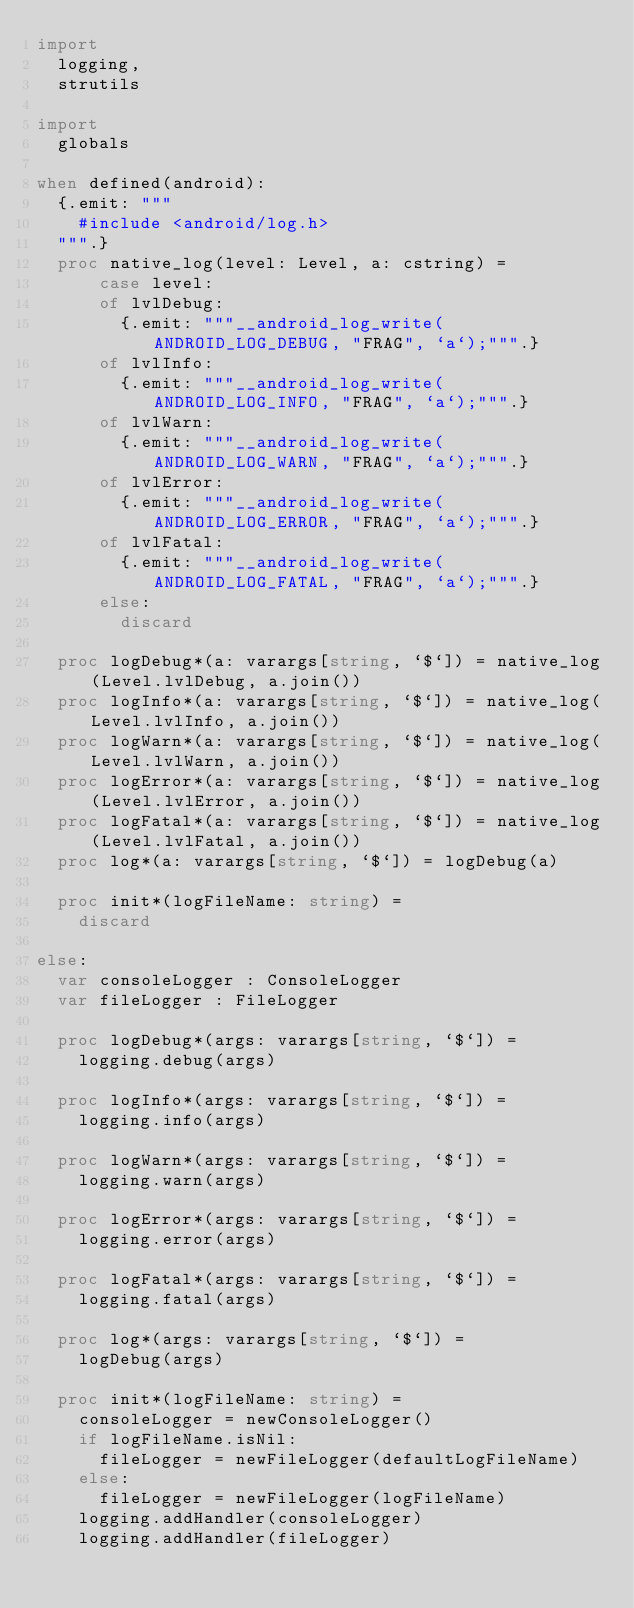Convert code to text. <code><loc_0><loc_0><loc_500><loc_500><_Nim_>import
  logging,
  strutils

import
  globals

when defined(android):
  {.emit: """
    #include <android/log.h>
  """.}
  proc native_log(level: Level, a: cstring) =
      case level:
      of lvlDebug:
        {.emit: """__android_log_write(ANDROID_LOG_DEBUG, "FRAG", `a`);""".}
      of lvlInfo:
        {.emit: """__android_log_write(ANDROID_LOG_INFO, "FRAG", `a`);""".}
      of lvlWarn:
        {.emit: """__android_log_write(ANDROID_LOG_WARN, "FRAG", `a`);""".}
      of lvlError:
        {.emit: """__android_log_write(ANDROID_LOG_ERROR, "FRAG", `a`);""".}
      of lvlFatal:
        {.emit: """__android_log_write(ANDROID_LOG_FATAL, "FRAG", `a`);""".}
      else:
        discard

  proc logDebug*(a: varargs[string, `$`]) = native_log(Level.lvlDebug, a.join())
  proc logInfo*(a: varargs[string, `$`]) = native_log(Level.lvlInfo, a.join())
  proc logWarn*(a: varargs[string, `$`]) = native_log(Level.lvlWarn, a.join())
  proc logError*(a: varargs[string, `$`]) = native_log(Level.lvlError, a.join())
  proc logFatal*(a: varargs[string, `$`]) = native_log(Level.lvlFatal, a.join())
  proc log*(a: varargs[string, `$`]) = logDebug(a)

  proc init*(logFileName: string) =
    discard

else:
  var consoleLogger : ConsoleLogger
  var fileLogger : FileLogger

  proc logDebug*(args: varargs[string, `$`]) =
    logging.debug(args)

  proc logInfo*(args: varargs[string, `$`]) =
    logging.info(args)

  proc logWarn*(args: varargs[string, `$`]) =
    logging.warn(args)

  proc logError*(args: varargs[string, `$`]) =
    logging.error(args)

  proc logFatal*(args: varargs[string, `$`]) =
    logging.fatal(args)

  proc log*(args: varargs[string, `$`]) =
    logDebug(args)

  proc init*(logFileName: string) =
    consoleLogger = newConsoleLogger()
    if logFileName.isNil:
      fileLogger = newFileLogger(defaultLogFileName)
    else:  
      fileLogger = newFileLogger(logFileName)
    logging.addHandler(consoleLogger)
    logging.addHandler(fileLogger)
</code> 